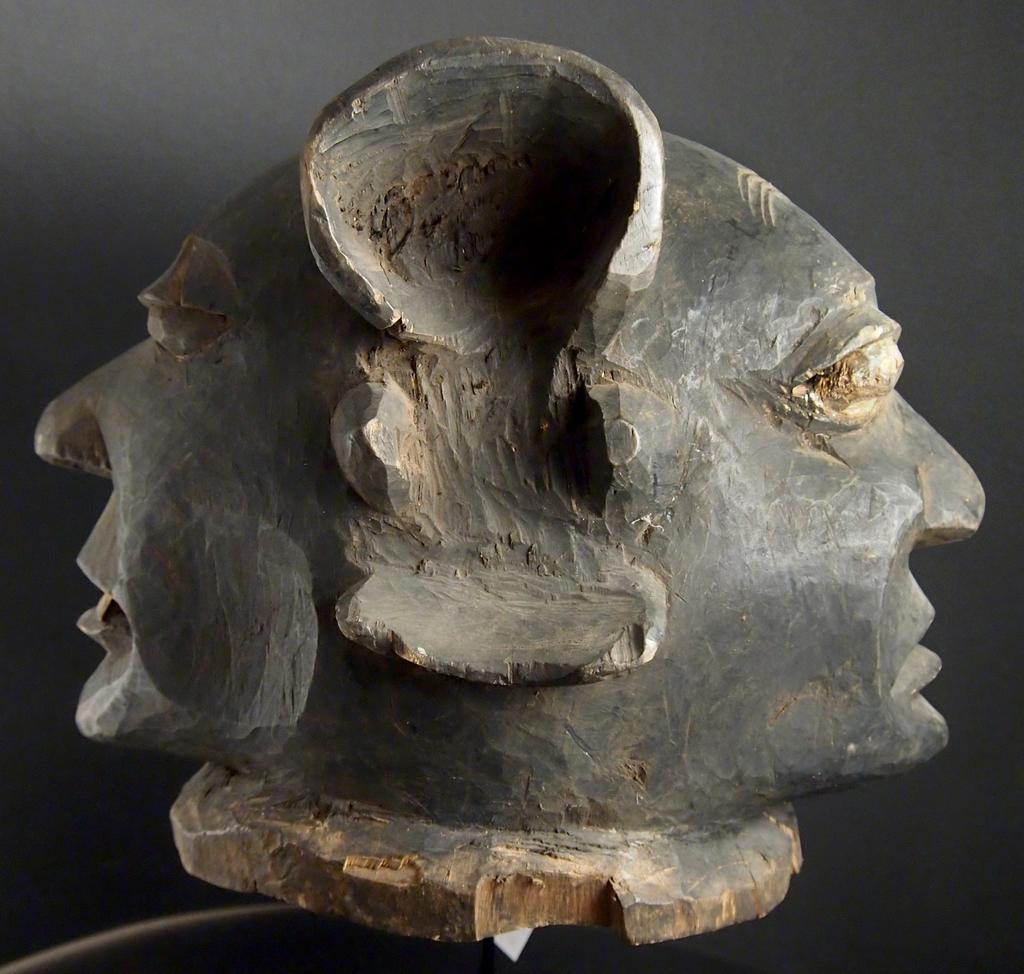What is the main subject of the image? There is a statue in the image. What can be observed about the background of the image? The background of the image is dark. What type of underwear is the statue wearing in the image? There is no underwear visible on the statue in the image. What kind of box is located near the statue in the image? There is no box present in the image; it only features a statue and a dark background. 